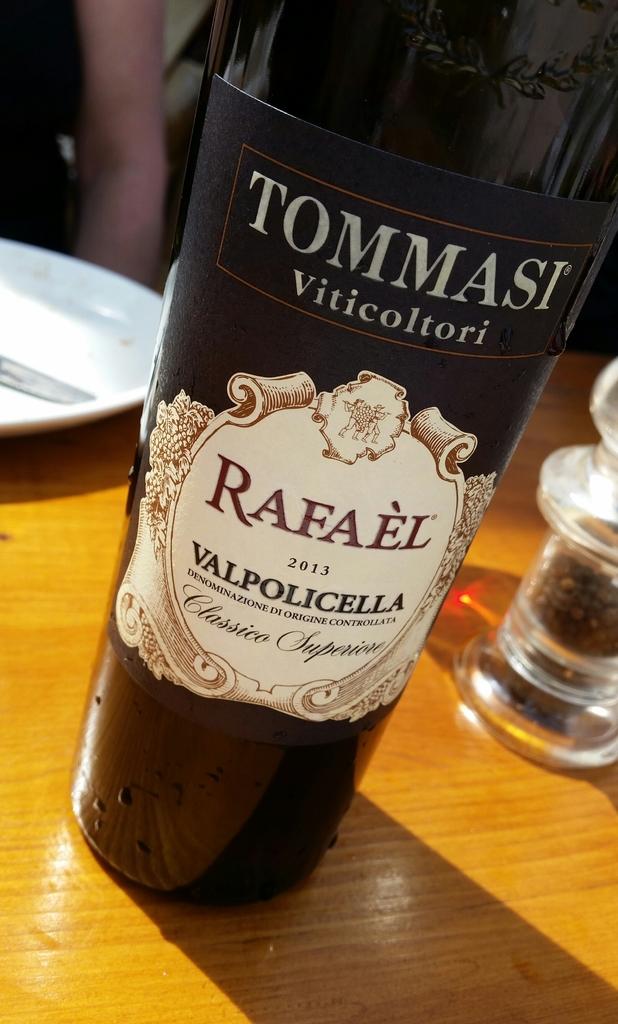What is the number written on the bottle?
Provide a succinct answer. 2013. 